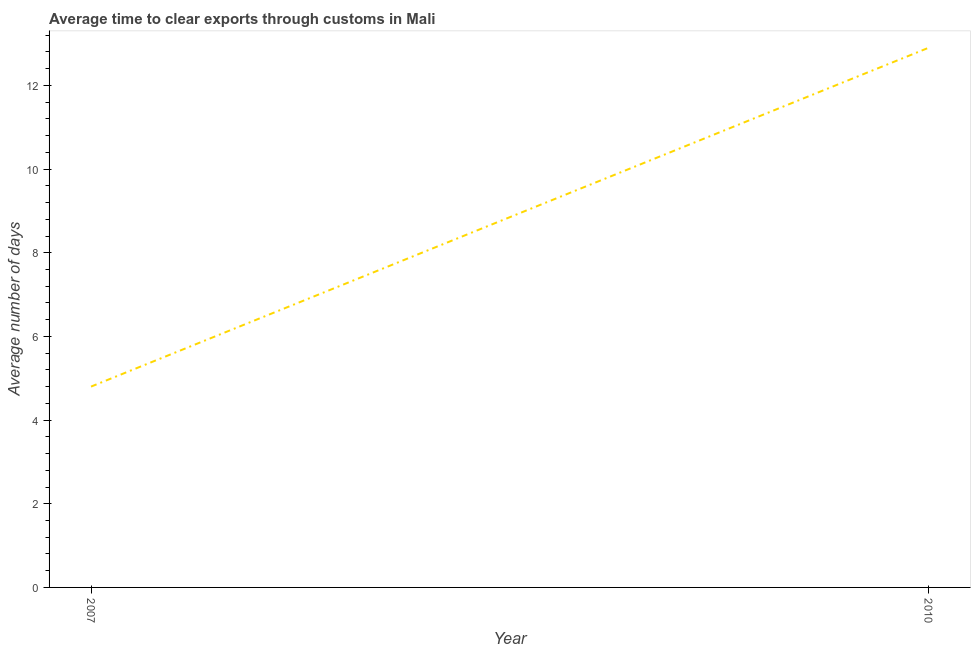What is the time to clear exports through customs in 2007?
Your response must be concise. 4.8. Across all years, what is the maximum time to clear exports through customs?
Keep it short and to the point. 12.9. In which year was the time to clear exports through customs minimum?
Provide a short and direct response. 2007. What is the difference between the time to clear exports through customs in 2007 and 2010?
Offer a very short reply. -8.1. What is the average time to clear exports through customs per year?
Offer a terse response. 8.85. What is the median time to clear exports through customs?
Make the answer very short. 8.85. In how many years, is the time to clear exports through customs greater than 4 days?
Your answer should be compact. 2. What is the ratio of the time to clear exports through customs in 2007 to that in 2010?
Provide a short and direct response. 0.37. Is the time to clear exports through customs in 2007 less than that in 2010?
Your answer should be very brief. Yes. In how many years, is the time to clear exports through customs greater than the average time to clear exports through customs taken over all years?
Offer a terse response. 1. Does the time to clear exports through customs monotonically increase over the years?
Keep it short and to the point. Yes. What is the difference between two consecutive major ticks on the Y-axis?
Ensure brevity in your answer.  2. What is the title of the graph?
Your response must be concise. Average time to clear exports through customs in Mali. What is the label or title of the Y-axis?
Your response must be concise. Average number of days. What is the Average number of days of 2007?
Keep it short and to the point. 4.8. What is the Average number of days in 2010?
Your answer should be compact. 12.9. What is the ratio of the Average number of days in 2007 to that in 2010?
Make the answer very short. 0.37. 